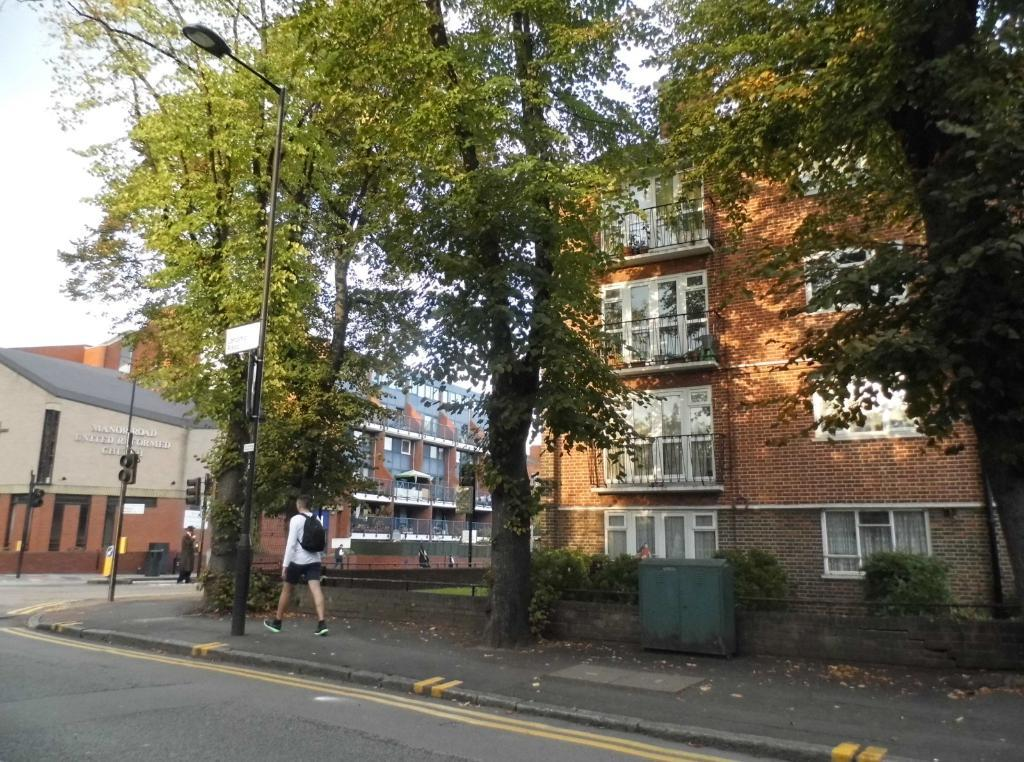What type of structures can be seen in the image? There are buildings in the image. What features do the buildings have? The buildings have windows. What natural elements are present in the image? There are trees in the image. What type of barrier can be seen in the image? There is fencing in the image. What type of street infrastructure is present in the image? There is a light pole and traffic signals in the image. What additional object can be seen in the image? There is a board in the image. What is the person in the image doing? A person is walking in the image. What is the person carrying? The person is wearing a bag. What is the color of the sky in the image? The sky is blue and white in color. Can you tell me how many roots are visible in the image? There are no roots present in the image. What type of yard is shown in the image? There is no yard present in the image. 